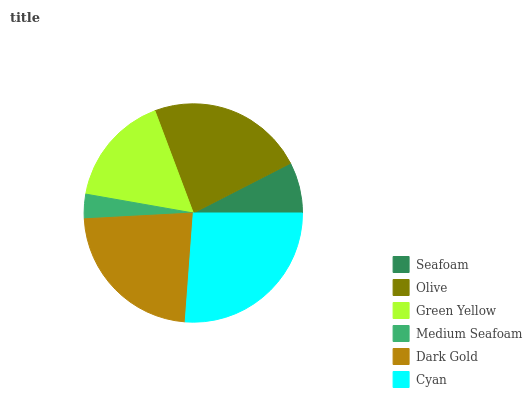Is Medium Seafoam the minimum?
Answer yes or no. Yes. Is Cyan the maximum?
Answer yes or no. Yes. Is Olive the minimum?
Answer yes or no. No. Is Olive the maximum?
Answer yes or no. No. Is Olive greater than Seafoam?
Answer yes or no. Yes. Is Seafoam less than Olive?
Answer yes or no. Yes. Is Seafoam greater than Olive?
Answer yes or no. No. Is Olive less than Seafoam?
Answer yes or no. No. Is Dark Gold the high median?
Answer yes or no. Yes. Is Green Yellow the low median?
Answer yes or no. Yes. Is Green Yellow the high median?
Answer yes or no. No. Is Cyan the low median?
Answer yes or no. No. 